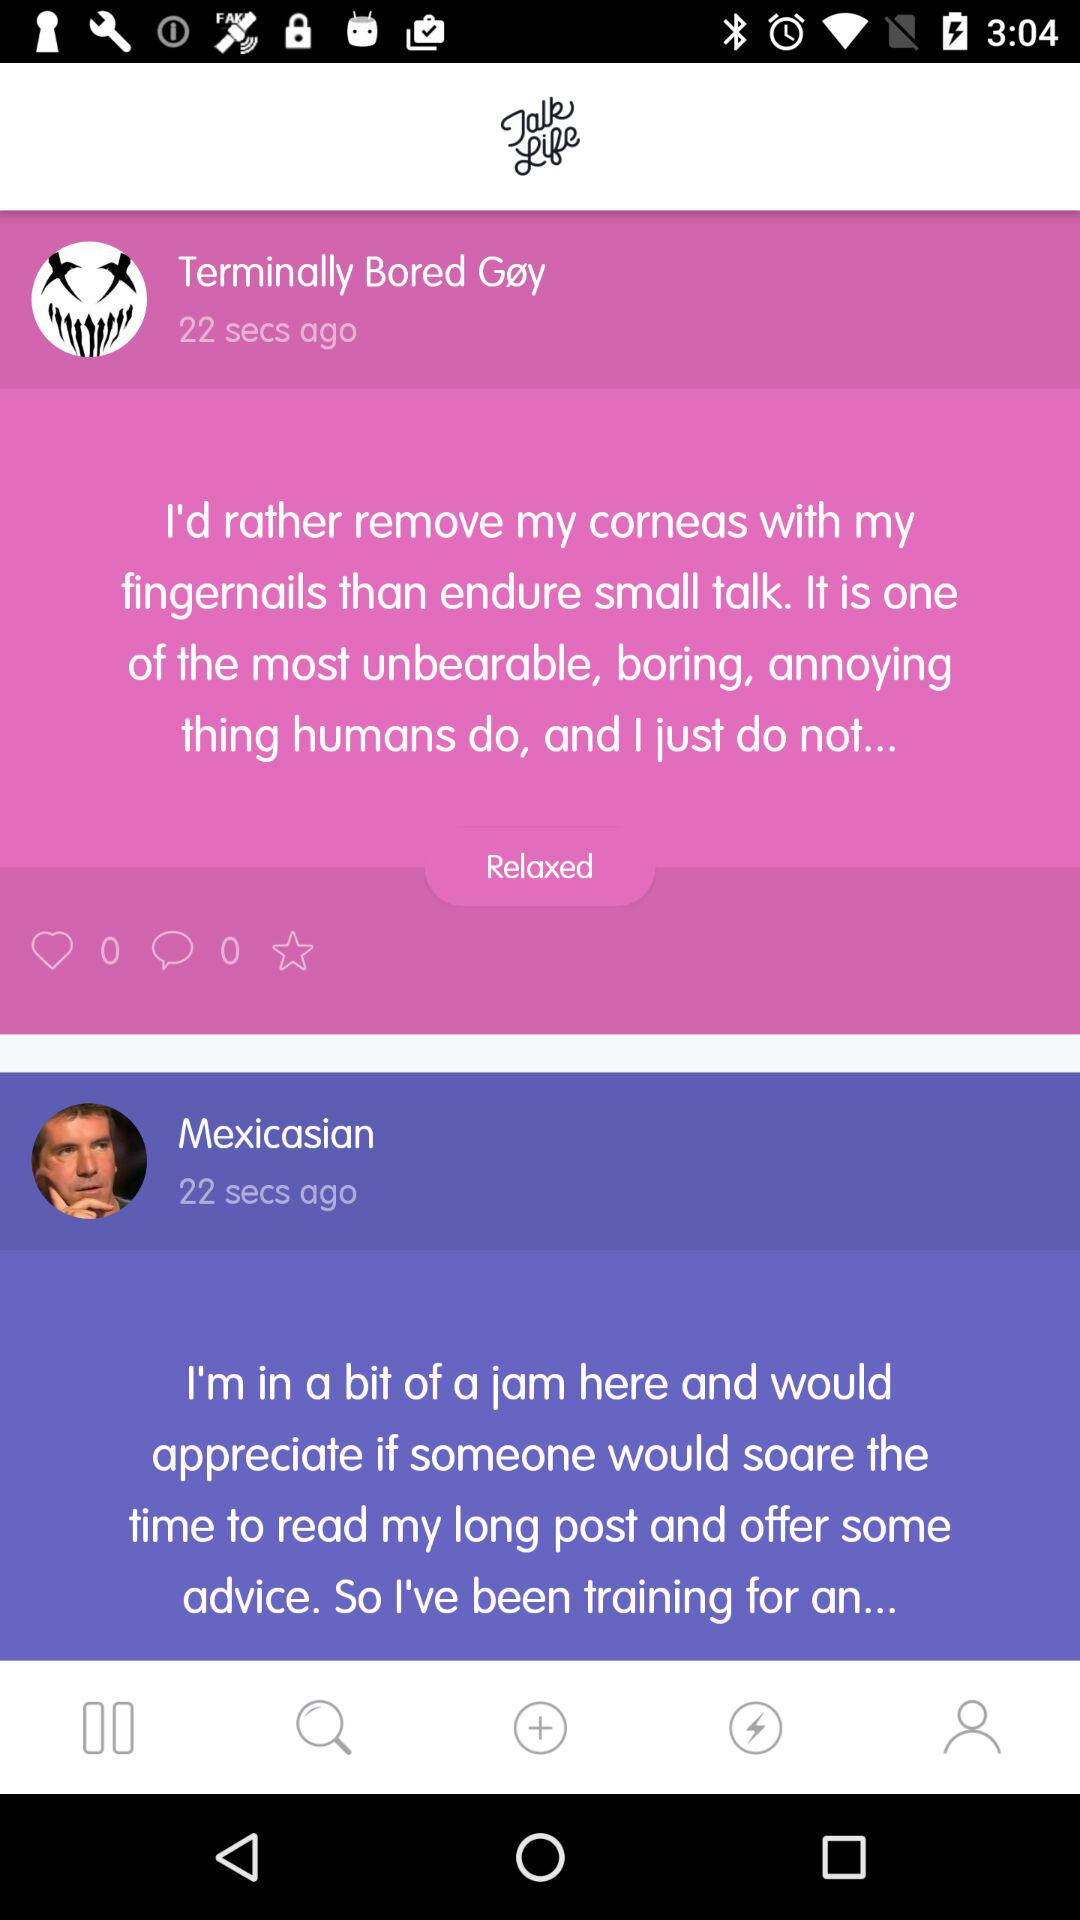How many likes are there of the post by "Terminally Bored Gøy"? The number of likes is 0. 